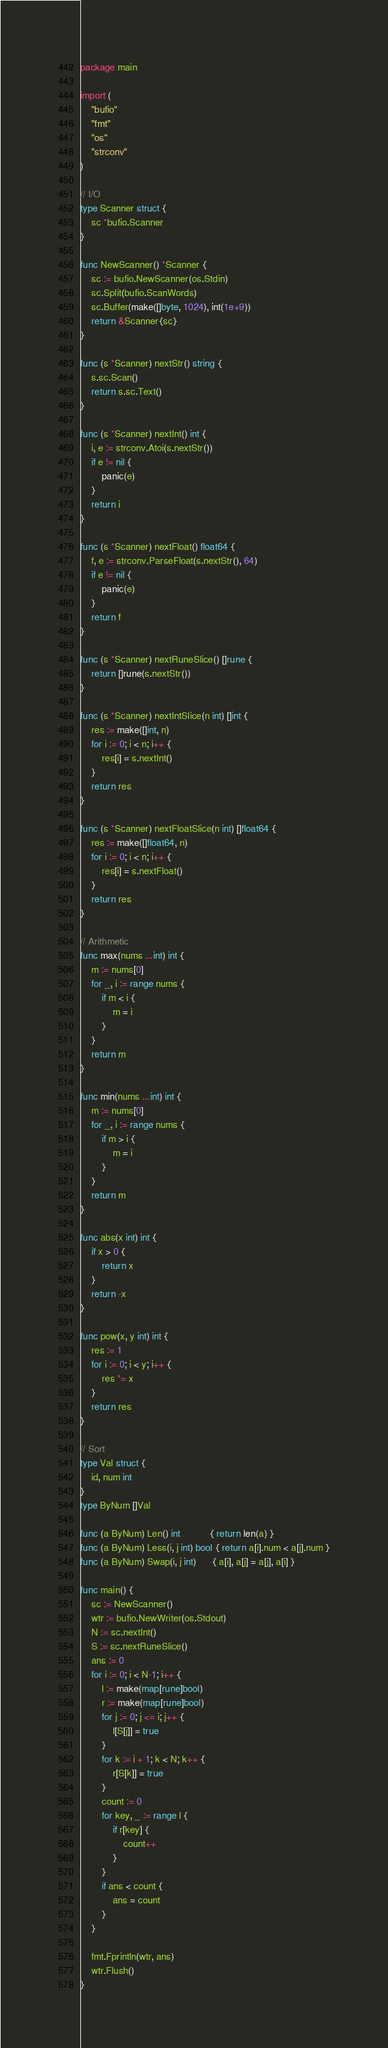<code> <loc_0><loc_0><loc_500><loc_500><_Go_>package main

import (
	"bufio"
	"fmt"
	"os"
	"strconv"
)

// I/O
type Scanner struct {
	sc *bufio.Scanner
}

func NewScanner() *Scanner {
	sc := bufio.NewScanner(os.Stdin)
	sc.Split(bufio.ScanWords)
	sc.Buffer(make([]byte, 1024), int(1e+9))
	return &Scanner{sc}
}

func (s *Scanner) nextStr() string {
	s.sc.Scan()
	return s.sc.Text()
}

func (s *Scanner) nextInt() int {
	i, e := strconv.Atoi(s.nextStr())
	if e != nil {
		panic(e)
	}
	return i
}

func (s *Scanner) nextFloat() float64 {
	f, e := strconv.ParseFloat(s.nextStr(), 64)
	if e != nil {
		panic(e)
	}
	return f
}

func (s *Scanner) nextRuneSlice() []rune {
	return []rune(s.nextStr())
}

func (s *Scanner) nextIntSlice(n int) []int {
	res := make([]int, n)
	for i := 0; i < n; i++ {
		res[i] = s.nextInt()
	}
	return res
}

func (s *Scanner) nextFloatSlice(n int) []float64 {
	res := make([]float64, n)
	for i := 0; i < n; i++ {
		res[i] = s.nextFloat()
	}
	return res
}

// Arithmetic
func max(nums ...int) int {
	m := nums[0]
	for _, i := range nums {
		if m < i {
			m = i
		}
	}
	return m
}

func min(nums ...int) int {
	m := nums[0]
	for _, i := range nums {
		if m > i {
			m = i
		}
	}
	return m
}

func abs(x int) int {
	if x > 0 {
		return x
	}
	return -x
}

func pow(x, y int) int {
	res := 1
	for i := 0; i < y; i++ {
		res *= x
	}
	return res
}

// Sort
type Val struct {
	id, num int
}
type ByNum []Val

func (a ByNum) Len() int           { return len(a) }
func (a ByNum) Less(i, j int) bool { return a[i].num < a[j].num }
func (a ByNum) Swap(i, j int)      { a[i], a[j] = a[j], a[i] }

func main() {
	sc := NewScanner()
	wtr := bufio.NewWriter(os.Stdout)
	N := sc.nextInt()
	S := sc.nextRuneSlice()
	ans := 0
	for i := 0; i < N-1; i++ {
		l := make(map[rune]bool)
		r := make(map[rune]bool)
		for j := 0; j <= i; j++ {
			l[S[j]] = true
		}
		for k := i + 1; k < N; k++ {
			r[S[k]] = true
		}
		count := 0
		for key, _ := range l {
			if r[key] {
				count++
			}
		}
		if ans < count {
			ans = count
		}
	}

	fmt.Fprintln(wtr, ans)
	wtr.Flush()
}
</code> 